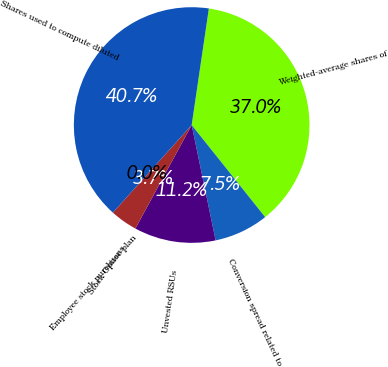<chart> <loc_0><loc_0><loc_500><loc_500><pie_chart><fcel>Weighted-average shares of<fcel>Conversion spread related to<fcel>Unvested RSUs<fcel>Stock Options<fcel>Employee stock purchase plan<fcel>Shares used to compute diluted<nl><fcel>36.95%<fcel>7.46%<fcel>11.19%<fcel>3.73%<fcel>0.0%<fcel>40.67%<nl></chart> 